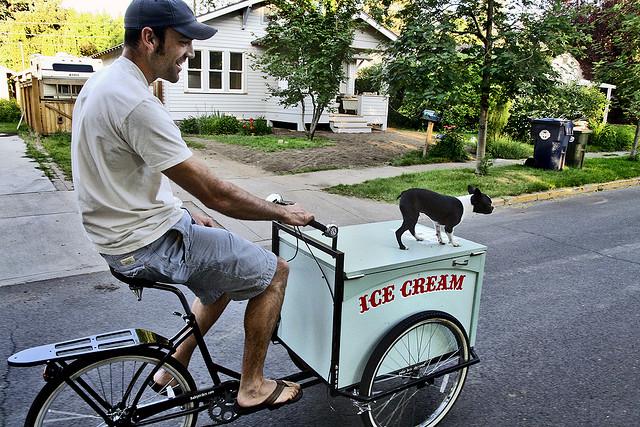What type of animal is on top of the ice cream box?
Be succinct. Dog. Bike or a car?
Short answer required. Bike. Where are the garbage containers?
Answer briefly. On grass. 